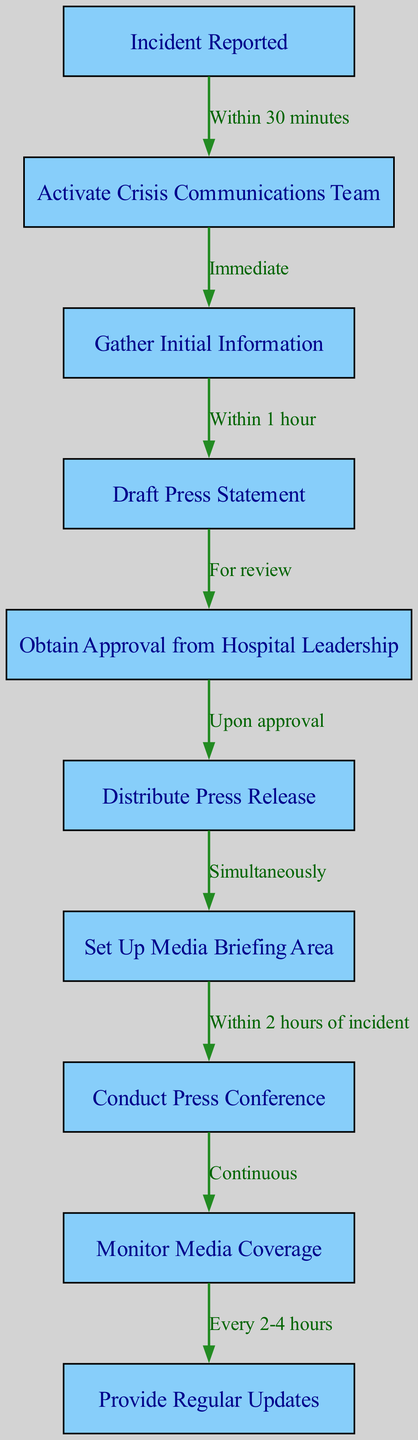What is the first node in the diagram? The first node, which signifies the beginning of the crisis communication workflow, is labeled "Incident Reported."
Answer: Incident Reported How many nodes are represented in the diagram? The diagram includes 10 nodes, as listed from the initial incident report to providing regular updates.
Answer: 10 What is the time frame for activating the Crisis Communications Team after an incident is reported? The activation of the Crisis Communications Team occurs immediately after the incident is reported, signifying urgency in response.
Answer: Immediate What is the relationship between "Draft Press Statement" and "Obtain Approval from Hospital Leadership"? The edge between these two nodes indicates that the drafting of the press statement is done for review by hospital leadership, illustrating a sequential process.
Answer: For review How often should media coverage be monitored? The diagram specifies that media coverage should be monitored continuously, reflecting an ongoing need for awareness during a crisis.
Answer: Continuous What task occurs simultaneously with the distribution of the press release? The diagram shows that setting up the media briefing area happens simultaneously with the distribution of the press release, indicating coordinated actions.
Answer: Simultaneously What is the maximum time allowed for setting up a press conference after the incident? The diagram indicates that the press conference must be conducted within 2 hours of the incident, providing a clear timeline for communication efforts.
Answer: Within 2 hours of incident After the press conference, how frequently should regular updates be provided? Regular updates are indicated to be provided every 2 to 4 hours, reflecting the need to keep the public and media informed consistently.
Answer: Every 2-4 hours What is the last step in the crisis communication workflow? The last step is to provide regular updates, which concludes the clinical pathway by ensuring continuous communication during the crisis.
Answer: Provide Regular Updates 